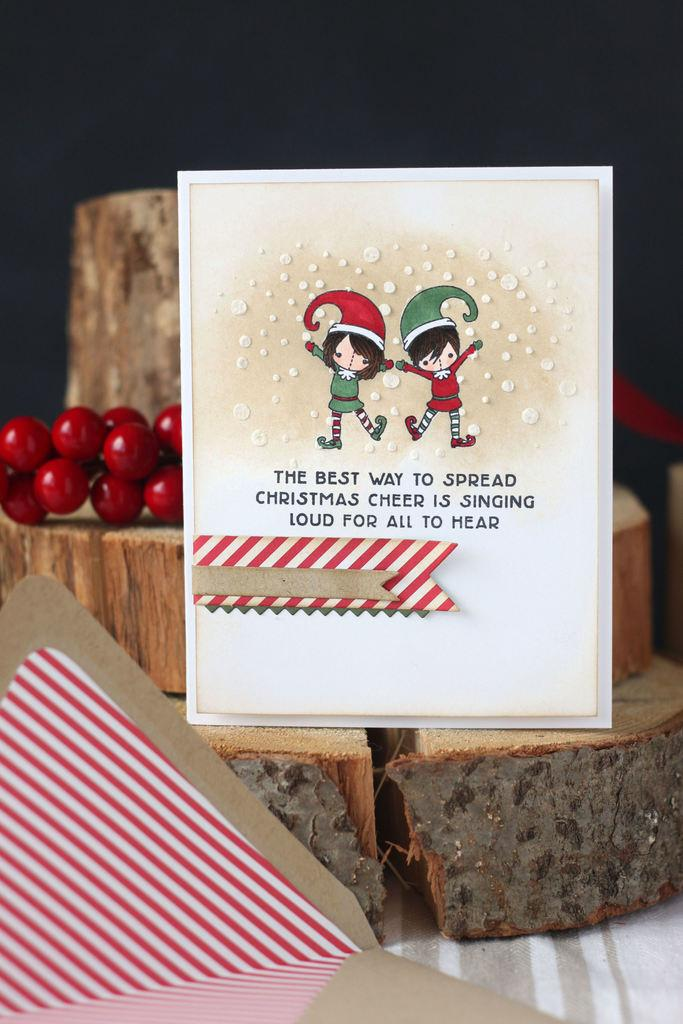What is the main subject of the image? There is a greeting card in the image. What is depicted on the greeting card? The greeting card features a boy and a girl dancing. What color are the fruits on the left side of the image? The fruits on the left side of the image are red. How many dolls can be seen destroying the rings in the image? There are no dolls or rings present in the image. 